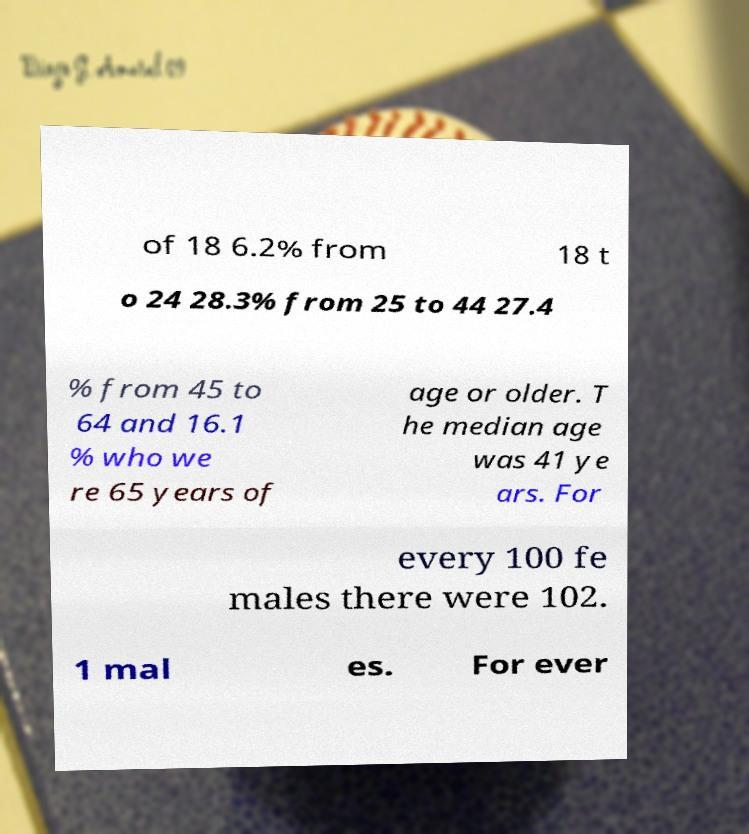Can you read and provide the text displayed in the image?This photo seems to have some interesting text. Can you extract and type it out for me? of 18 6.2% from 18 t o 24 28.3% from 25 to 44 27.4 % from 45 to 64 and 16.1 % who we re 65 years of age or older. T he median age was 41 ye ars. For every 100 fe males there were 102. 1 mal es. For ever 